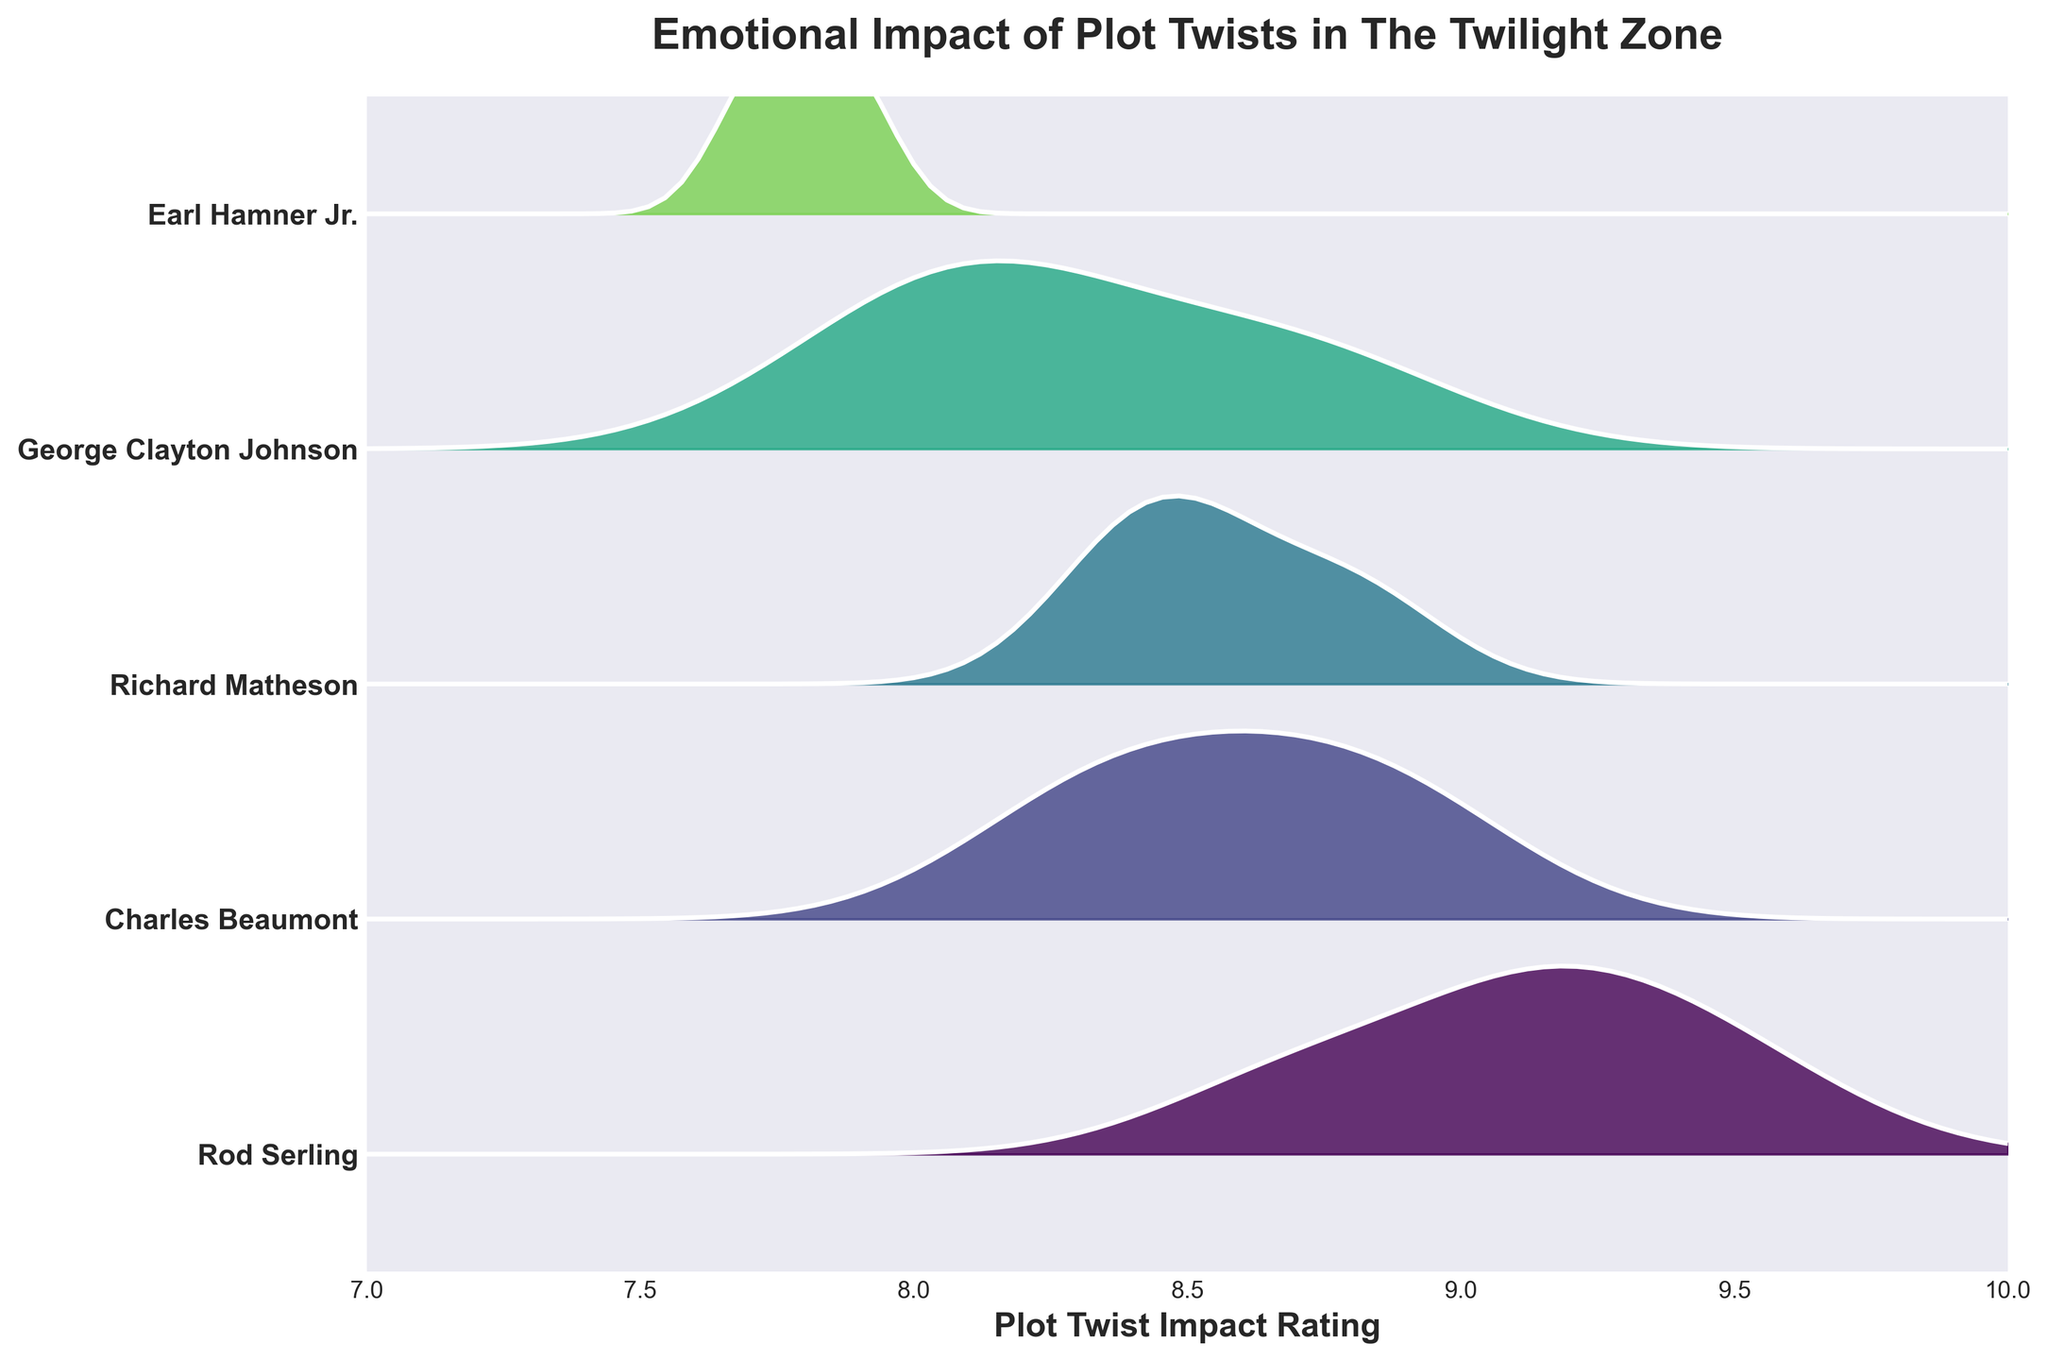What is the title of the plot? The title is usually found at the top of the figure where it summarizes the content. In this case, it conveys the central theme of the plot.
Answer: Emotional Impact of Plot Twists in The Twilight Zone Which writer has the highest peak on the plot? By comparing the ridgeline plots, we identify the plot with the highest peak. This corresponds to the writer with the greatest emotional impact as shown in the y-axis.
Answer: Rod Serling How many writers' emotional impact distributions are shown in the plot? Each distribution is associated with a different writer, and the distinct ridgelines on the y-axis represent these writers. Counting them gives the total number.
Answer: 5 Which writer has the widest distribution in terms of emotional impact ratings? The width of a distribution can be gauged by observing the spread of the ridgeline plot. The writer whose ridgeline covers the largest range on the x-axis has the widest distribution.
Answer: Rod Serling What is the approximate range of plot twist impact for Earl Hamner Jr.? The range can be determined by noting the start and end points of Earl Hamner Jr.'s distribution on the x-axis.
Answer: 7.7 to 7.9 Which writers have similar peak heights and lie closest to each other on the y-axis? Comparing the peak heights visually and checking the y-axis alignment helps identify which writers' distributions are similar and closely spaced.
Answer: George Clayton Johnson and Richard Matheson Is there a writer whose emotional impact distribution does not exceed an 8.8 rating? By observing the peaks of the ridgeline plots, we check if any writer's maximum value falls below 8.8 on the x-axis.
Answer: Earl Hamner Jr Which writer shows the most consistent emotional impact ratings? The consistency of ratings is implied by the narrowness of the distribution; a tightly-packed ridgeline plot indicates little variation.
Answer: Earl Hamner Jr What is the hardest question you would likely ask based on this figure? The hardest question involves synthesizing information from multiple writers' distributions, such as comparing their ranges and peak heights simultaneously.
Answer: Which writer has the highest average emotional impact rating and how does this compare with the writer having the most varied ratings? 